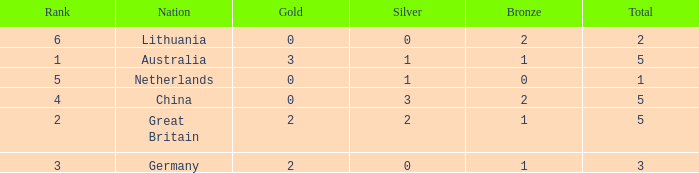What is the average Gold when the rank is less than 3 and the bronze is less than 1? None. 